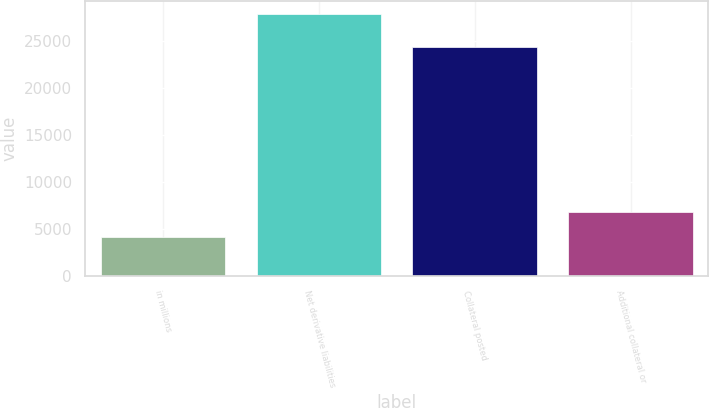<chart> <loc_0><loc_0><loc_500><loc_500><bar_chart><fcel>in millions<fcel>Net derivative liabilities<fcel>Collateral posted<fcel>Additional collateral or<nl><fcel>4169.1<fcel>27885<fcel>24296<fcel>6804.2<nl></chart> 